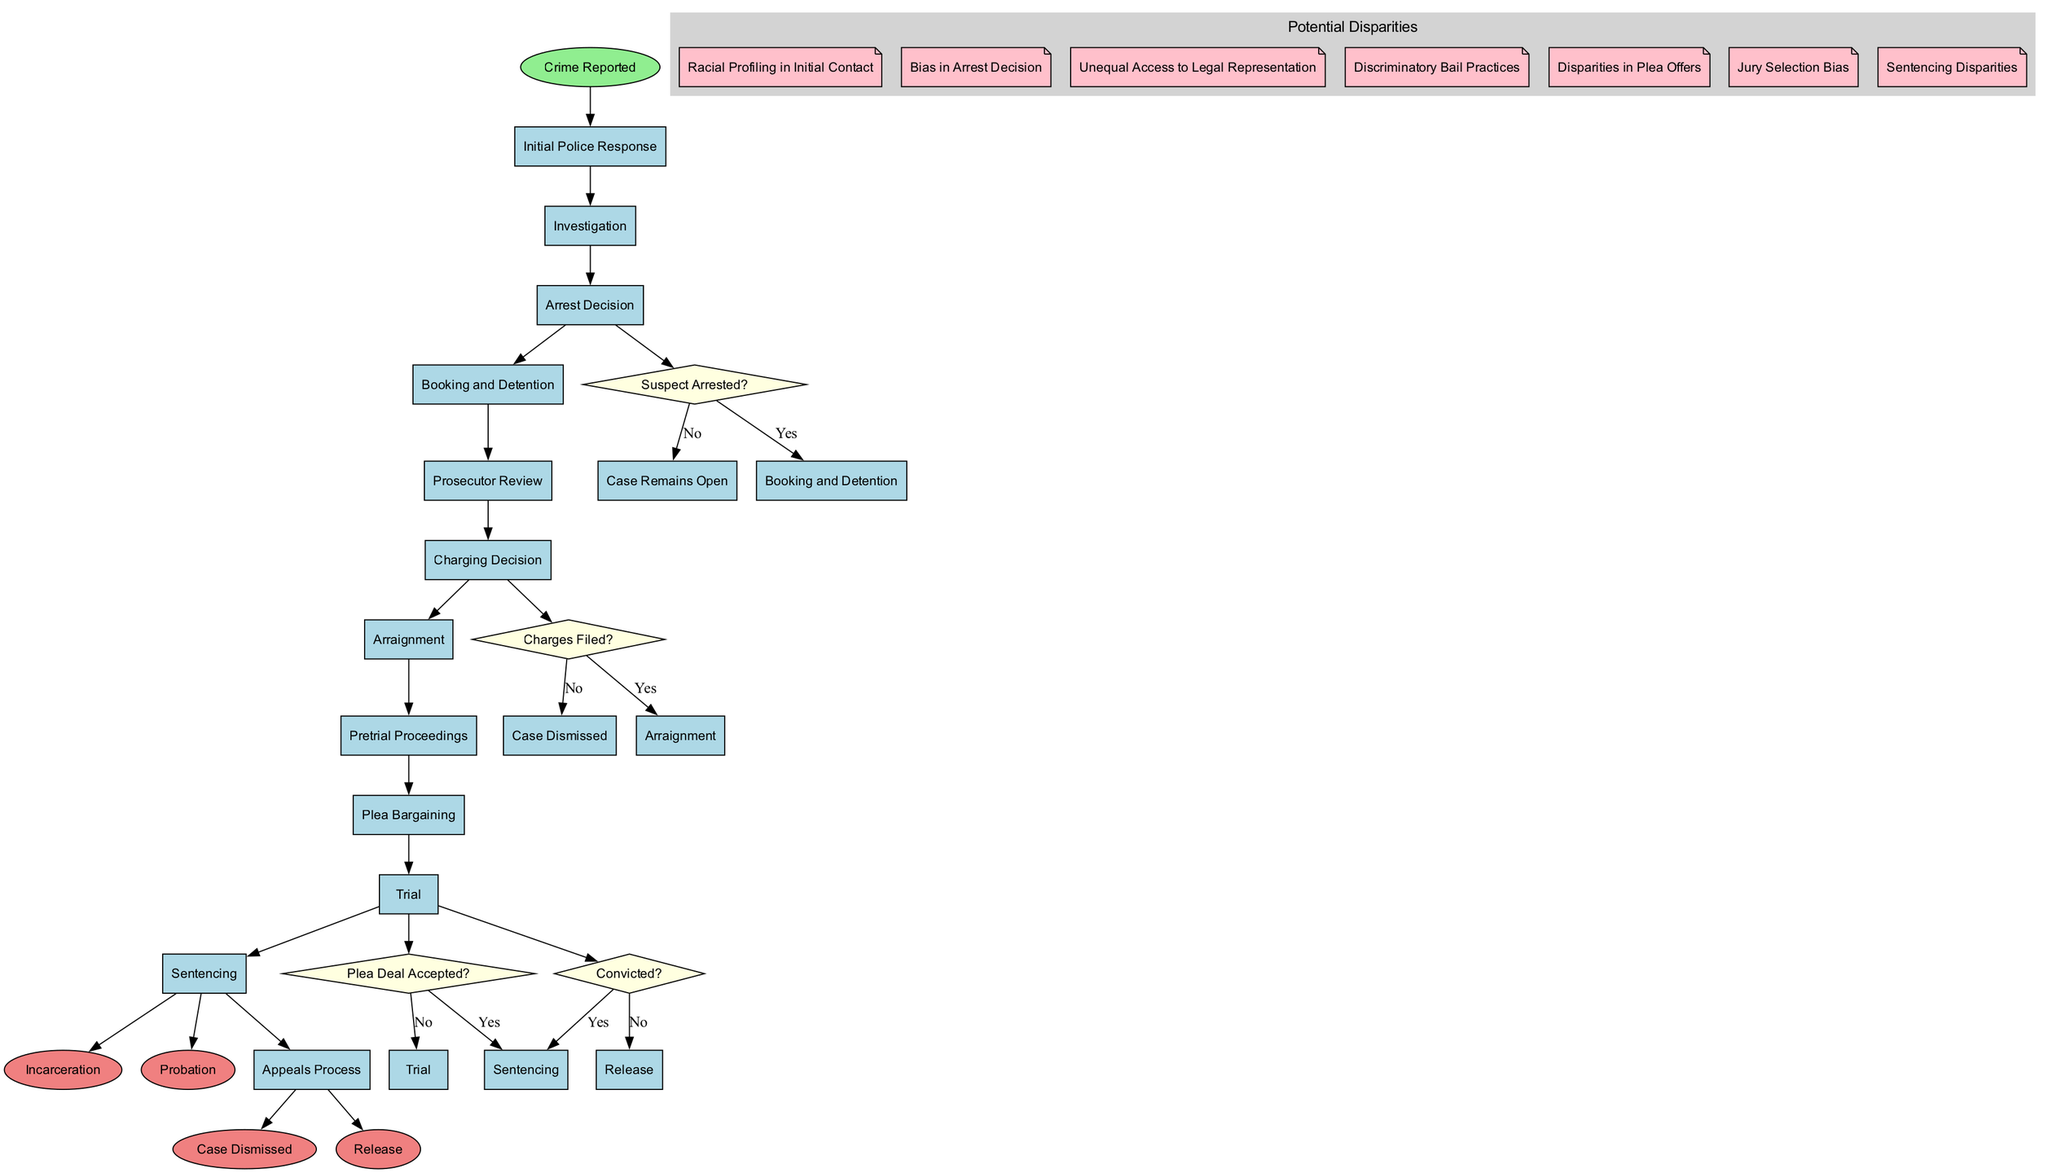What is the starting node of the diagram? The start node is labeled "Crime Reported." Therefore, this directly identifies the initial point of the process outlined in the diagram.
Answer: Crime Reported How many activities are there in the diagram? The list of activities includes twelve distinct elements. Counting each one in the provided list yields this total.
Answer: 12 What happens if there is no suspect arrested? If the answer to "Suspect Arrested?" is no, the next step is indicated as "Case Remains Open." The path based on this decision leads to a halted progression in the diagram.
Answer: Case Remains Open Which node follows "Plea Deal Accepted?" A "Yes" to "Plea Deal Accepted?" leads to "Sentencing," as indicated by the edge from this decision point to the subsequent activity, reflecting the process flow.
Answer: Sentencing What are the potential disparities related to arrest decisions? This disparity focuses on "Bias in Arrest Decision," as indicated by the specific mention of this issue regarding fairness in decision-making within the justice system.
Answer: Bias in Arrest Decision If the charging decision is "No," what is the outcome? The result of answering "No" to "Charges Filed?" is "Case Dismissed," thereby concluding this branch of the pathway illustrated in the diagram.
Answer: Case Dismissed How many decision points are there in the diagram? There are four distinct decision points present in the diagram, as detailed in the provided information regarding the decision-making phases.
Answer: 4 What is the outcome if a case progresses from trial and results in a conviction? Following a conviction outcome from "Trial," the next activity is "Sentencing," connecting the result of the trial to the next procedural step.
Answer: Sentencing What potential disparity is associated with jury selection? "Jury Selection Bias" is noted as a potential disparity, directly reflecting on how jury composition might unfairly affect case outcomes based on race or background.
Answer: Jury Selection Bias 